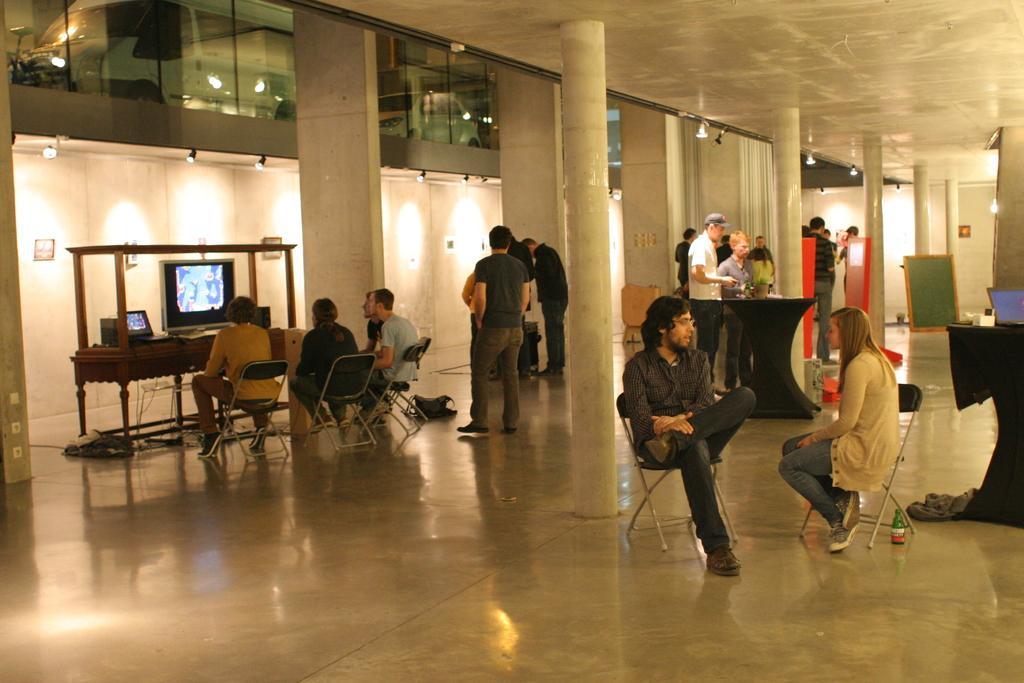How would you summarize this image in a sentence or two? In the middle of the image few persons are standing. Bottom right side of the image two people are sitting on a chair and there is a table on the table there is a laptop. Top right side of the image few people are standing. At the top of the image there is a roof and lights. Bottom left side of the image few people sitting on a chair and looking in to the screen. 